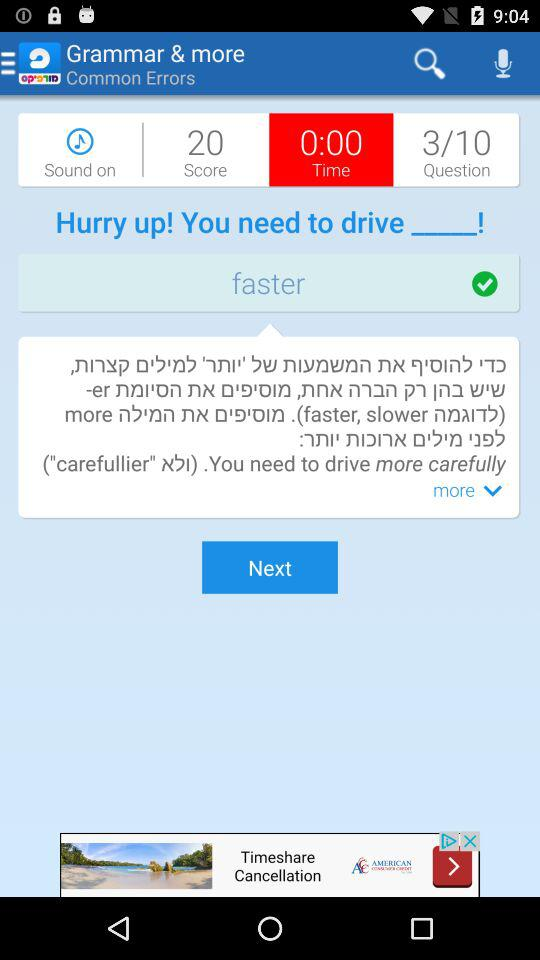What is the total score? The total score is 20. 